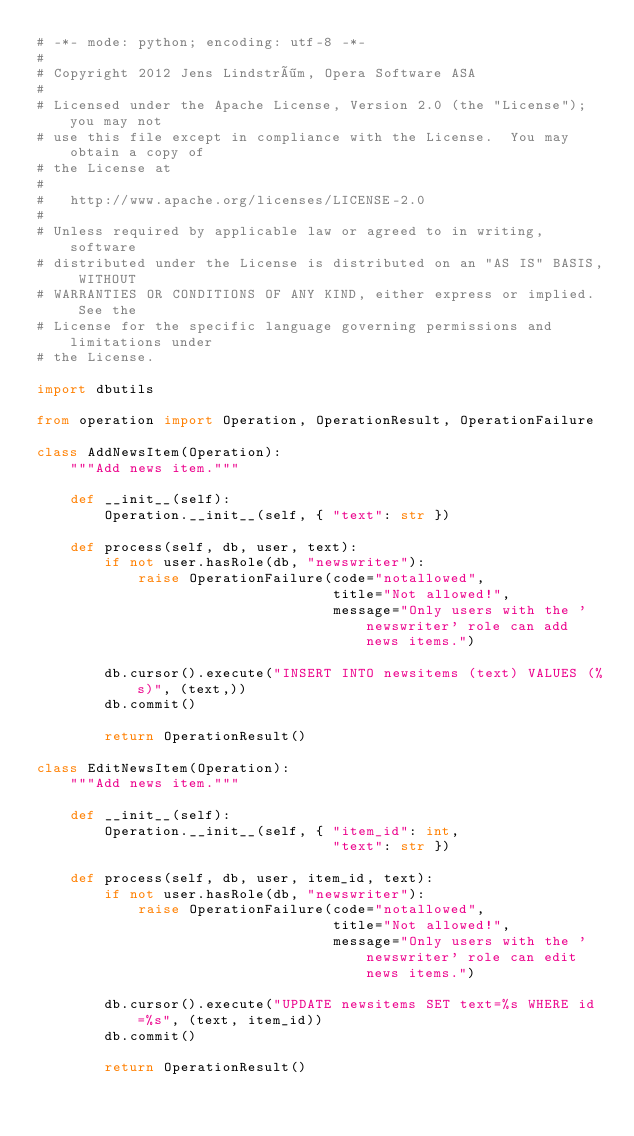<code> <loc_0><loc_0><loc_500><loc_500><_Python_># -*- mode: python; encoding: utf-8 -*-
#
# Copyright 2012 Jens Lindström, Opera Software ASA
#
# Licensed under the Apache License, Version 2.0 (the "License"); you may not
# use this file except in compliance with the License.  You may obtain a copy of
# the License at
#
#   http://www.apache.org/licenses/LICENSE-2.0
#
# Unless required by applicable law or agreed to in writing, software
# distributed under the License is distributed on an "AS IS" BASIS, WITHOUT
# WARRANTIES OR CONDITIONS OF ANY KIND, either express or implied.  See the
# License for the specific language governing permissions and limitations under
# the License.

import dbutils

from operation import Operation, OperationResult, OperationFailure

class AddNewsItem(Operation):
    """Add news item."""

    def __init__(self):
        Operation.__init__(self, { "text": str })

    def process(self, db, user, text):
        if not user.hasRole(db, "newswriter"):
            raise OperationFailure(code="notallowed",
                                   title="Not allowed!",
                                   message="Only users with the 'newswriter' role can add news items.")

        db.cursor().execute("INSERT INTO newsitems (text) VALUES (%s)", (text,))
        db.commit()

        return OperationResult()

class EditNewsItem(Operation):
    """Add news item."""

    def __init__(self):
        Operation.__init__(self, { "item_id": int,
                                   "text": str })

    def process(self, db, user, item_id, text):
        if not user.hasRole(db, "newswriter"):
            raise OperationFailure(code="notallowed",
                                   title="Not allowed!",
                                   message="Only users with the 'newswriter' role can edit news items.")

        db.cursor().execute("UPDATE newsitems SET text=%s WHERE id=%s", (text, item_id))
        db.commit()

        return OperationResult()
</code> 